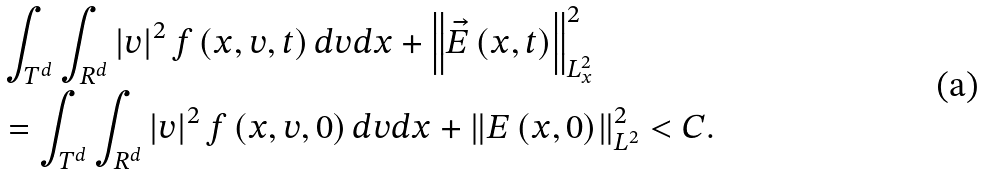<formula> <loc_0><loc_0><loc_500><loc_500>& \int _ { T ^ { d } } \int _ { R ^ { d } } \left | v \right | ^ { 2 } f \left ( x , v , t \right ) d v d x + \left \| \vec { E } \left ( x , t \right ) \right \| _ { L _ { x } ^ { 2 } } ^ { 2 } \\ & = \int _ { T ^ { d } } \int _ { R ^ { d } } \left | v \right | ^ { 2 } f \left ( x , v , 0 \right ) d v d x + \left \| E \left ( x , 0 \right ) \right \| _ { L ^ { 2 } } ^ { 2 } < C .</formula> 